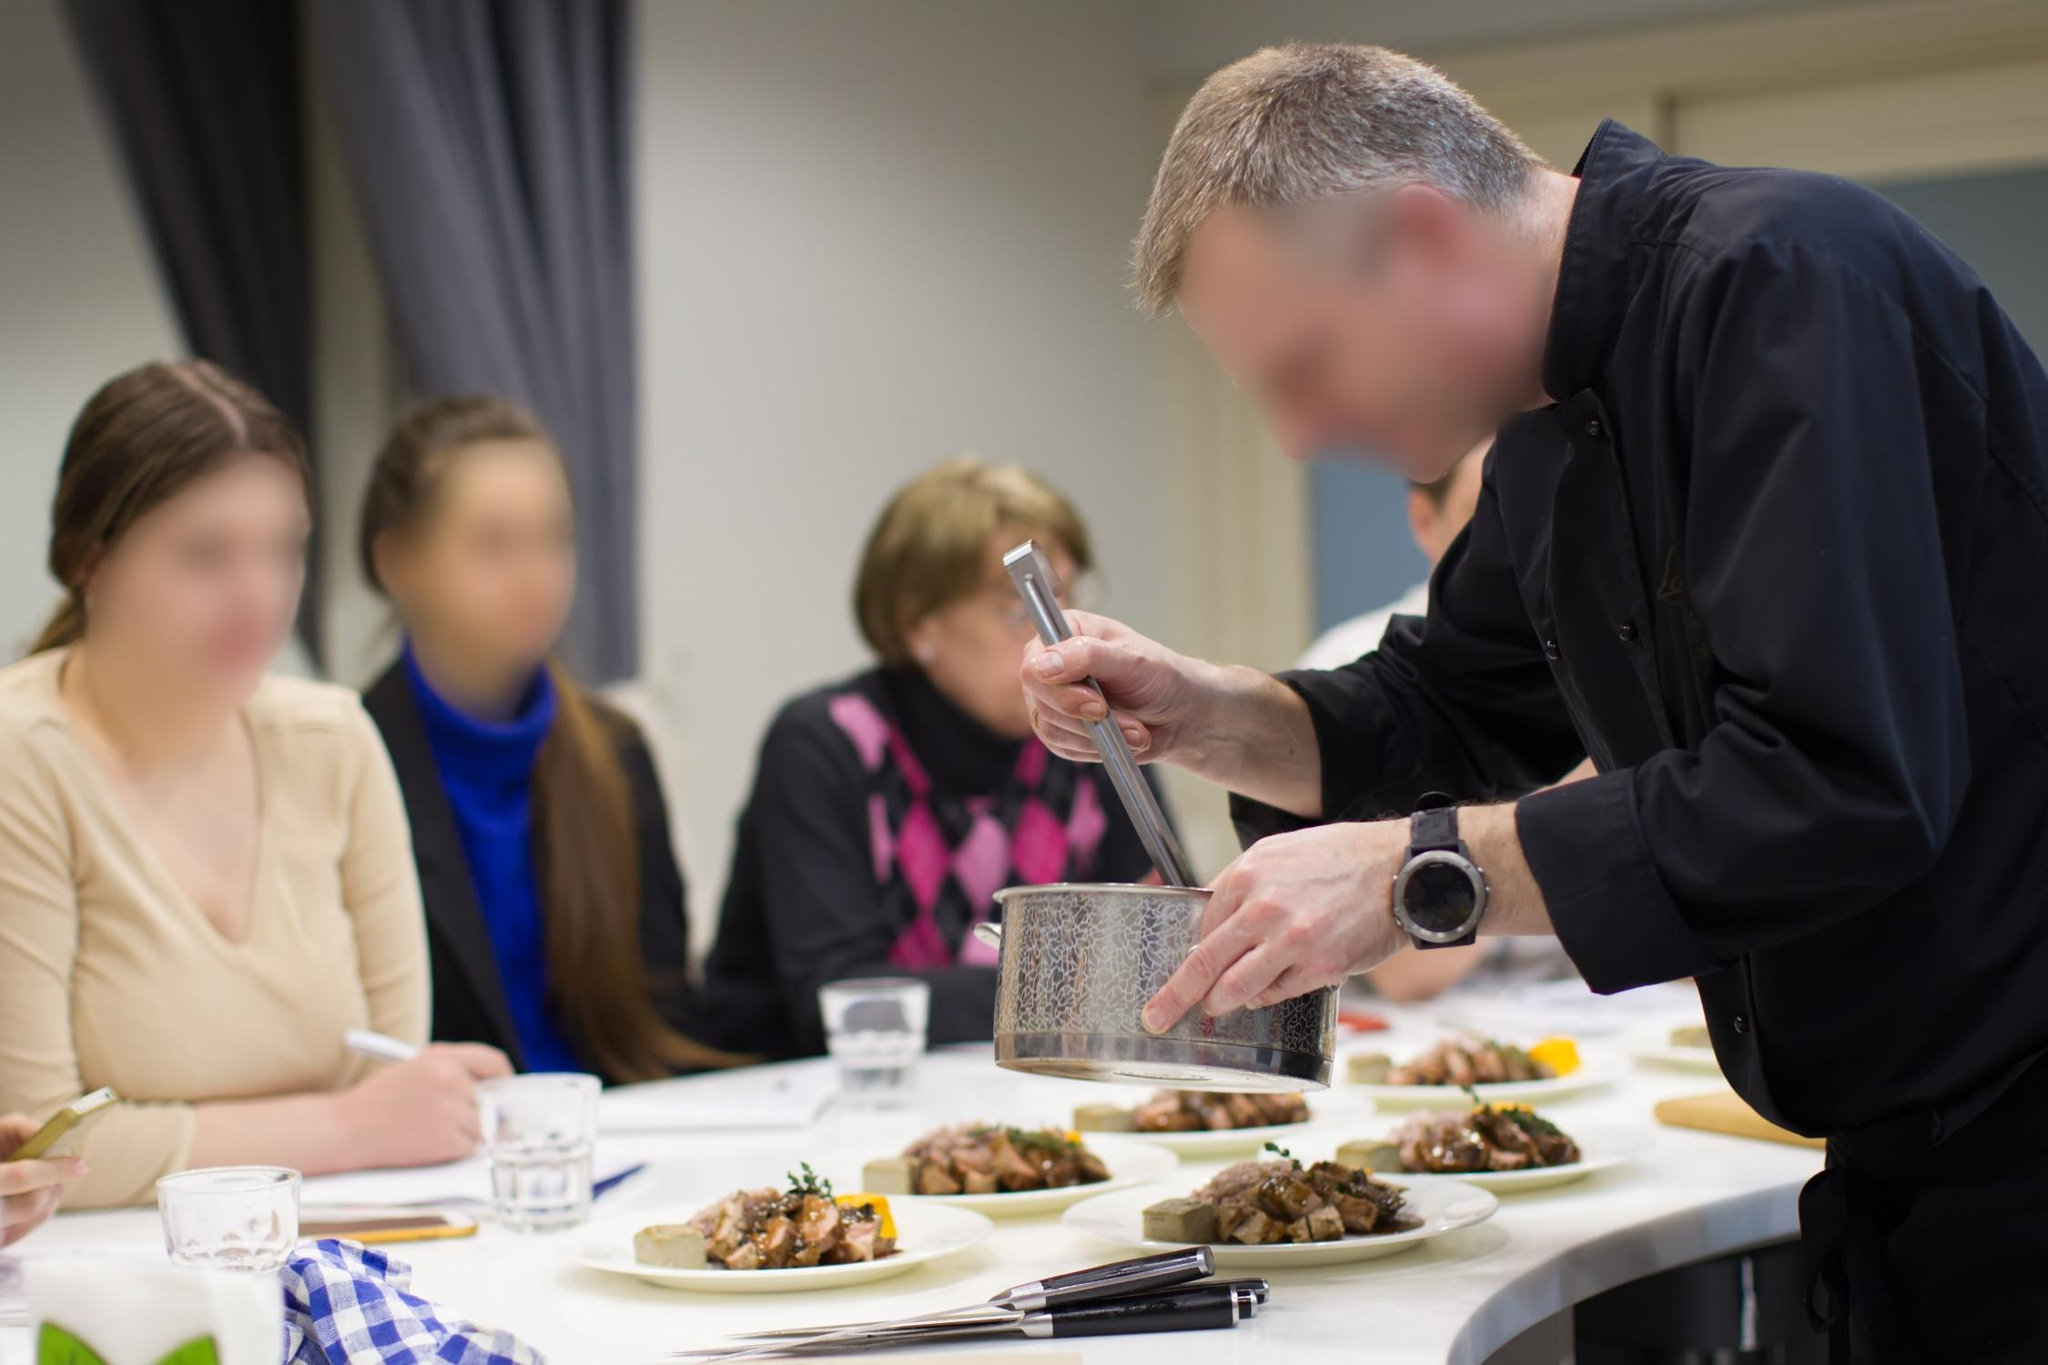Can you detail the importance of a clean and organized work space in the kitchen as depicted here? A clean and organized workspace is crucial in the kitchen for several reasons, as depicted in the image. Firstly, it ensures safety by minimizing the risk of accidents such as cuts or spills. An organized counter also enhances efficiency, allowing the chef to locate ingredients and utensils quickly, thereby maintaining the flow of cooking without unnecessary interruptions. Additionally, cleanliness reflects professionalism and hygiene, which are essential for food safety and customer satisfaction. The structured layout of the workspace in the image demonstrates these principles, illustrating the importance of preparation and meticulous attention to detail in delivering a high-quality culinary experience. 